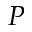Convert formula to latex. <formula><loc_0><loc_0><loc_500><loc_500>P</formula> 